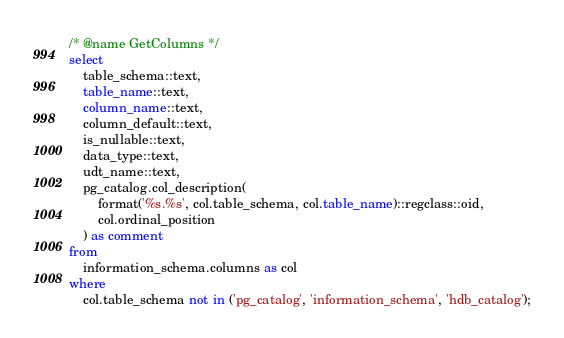Convert code to text. <code><loc_0><loc_0><loc_500><loc_500><_SQL_>/* @name GetColumns */
select
    table_schema::text,
    table_name::text,
    column_name::text,
    column_default::text,
    is_nullable::text,
    data_type::text,
    udt_name::text,
    pg_catalog.col_description(
        format('%s.%s', col.table_schema, col.table_name)::regclass::oid,
        col.ordinal_position
    ) as comment
from
    information_schema.columns as col
where
    col.table_schema not in ('pg_catalog', 'information_schema', 'hdb_catalog');</code> 